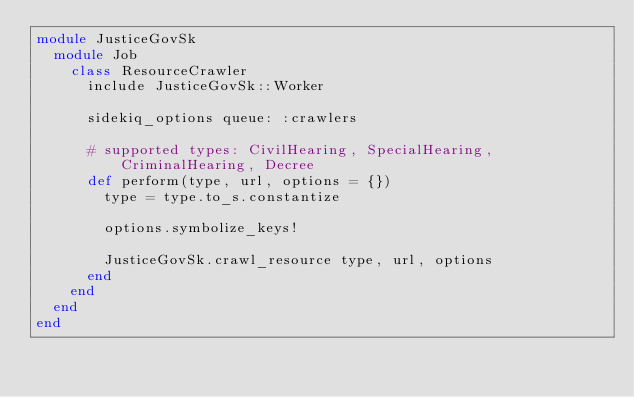Convert code to text. <code><loc_0><loc_0><loc_500><loc_500><_Ruby_>module JusticeGovSk
  module Job
    class ResourceCrawler
      include JusticeGovSk::Worker

      sidekiq_options queue: :crawlers

      # supported types: CivilHearing, SpecialHearing, CriminalHearing, Decree
      def perform(type, url, options = {})
        type = type.to_s.constantize

        options.symbolize_keys!

        JusticeGovSk.crawl_resource type, url, options
      end
    end
  end
end
</code> 